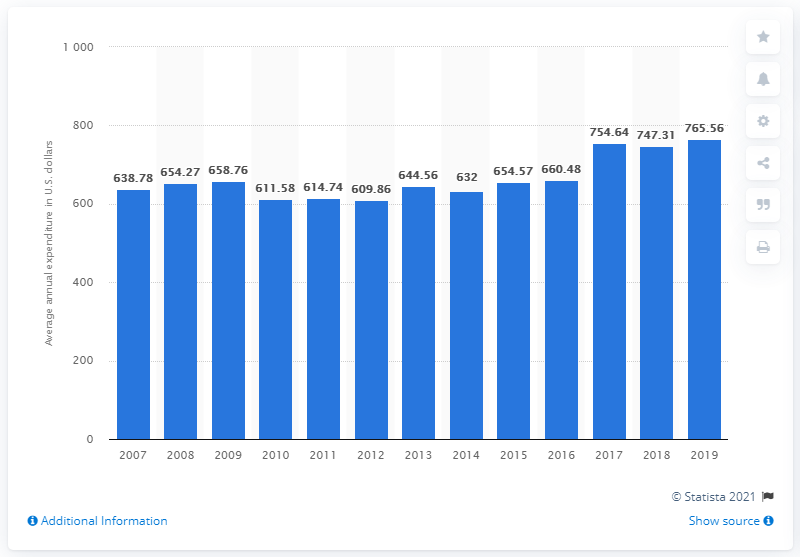Give some essential details in this illustration. In 2019, the average expenditure on housekeeping supplies per consumer unit in the United States was $765.56. 